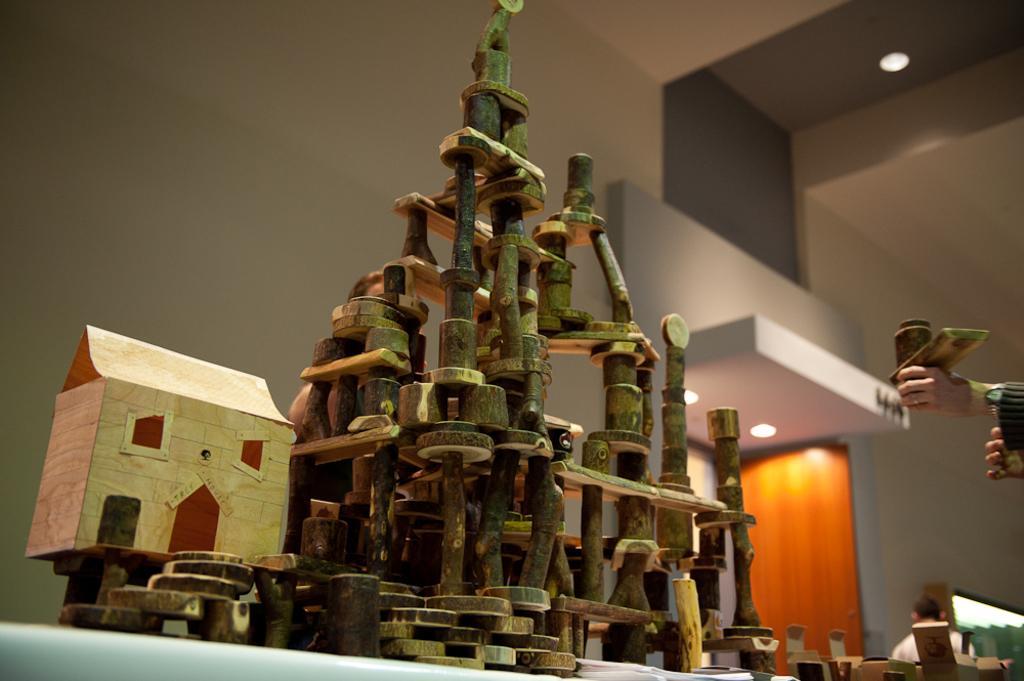How would you summarize this image in a sentence or two? In the foreground of this image, there is a wooden structure on a table. On the right, there is a person's hand holding an object. In the background, there are few objects, a man, lights, wall and the ceiling. 